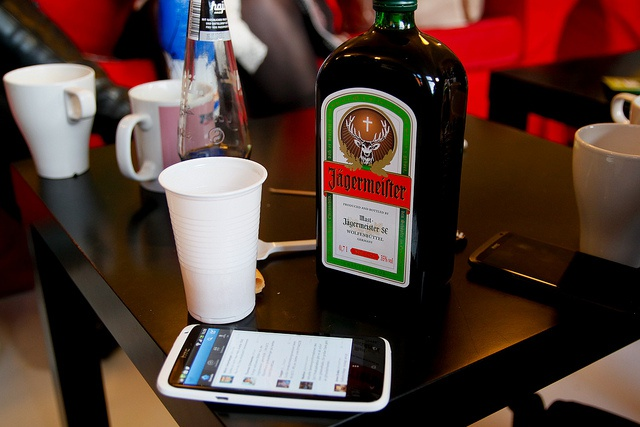Describe the objects in this image and their specific colors. I can see dining table in black, lightgray, maroon, and darkgray tones, bottle in black, darkgray, darkgreen, and red tones, cell phone in black, lightgray, maroon, and gray tones, couch in black, red, and maroon tones, and cup in black, lightgray, tan, and darkgray tones in this image. 